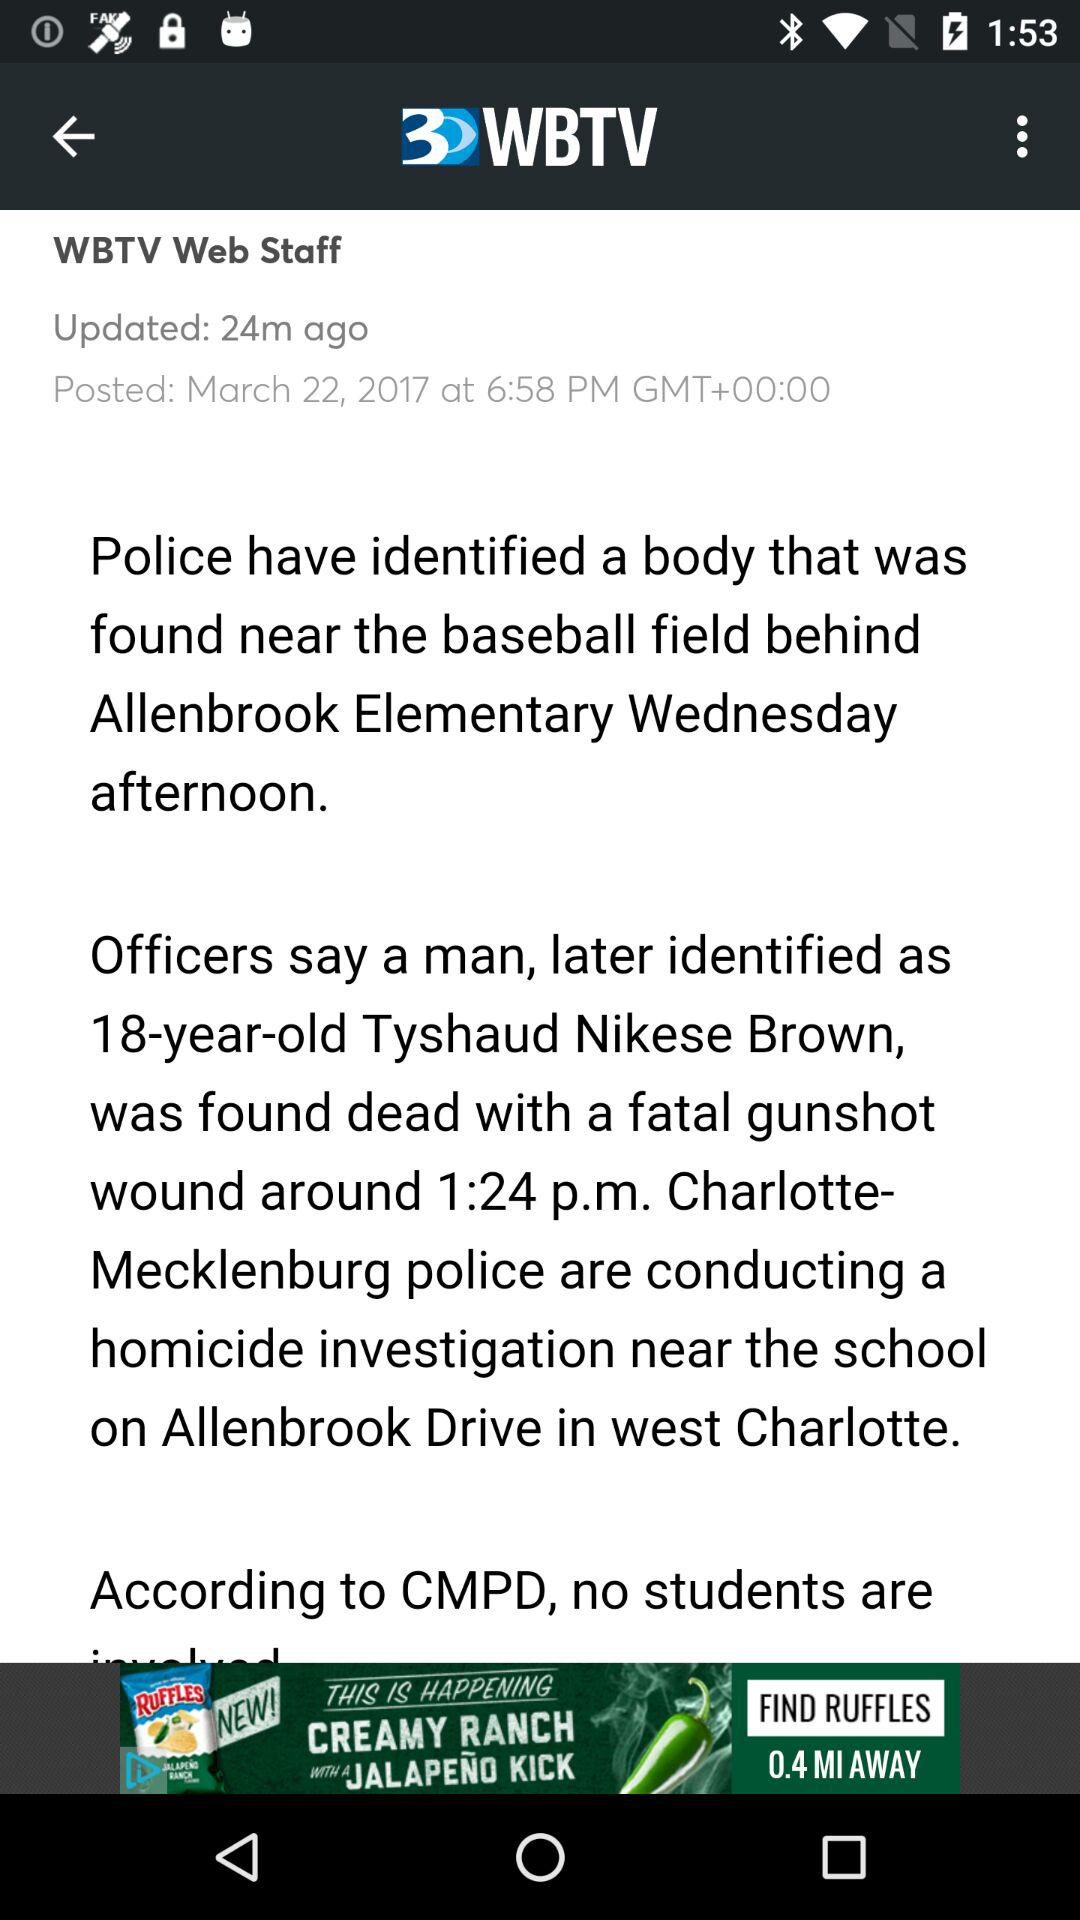How many minutes ago was the story posted?
Answer the question using a single word or phrase. 24 